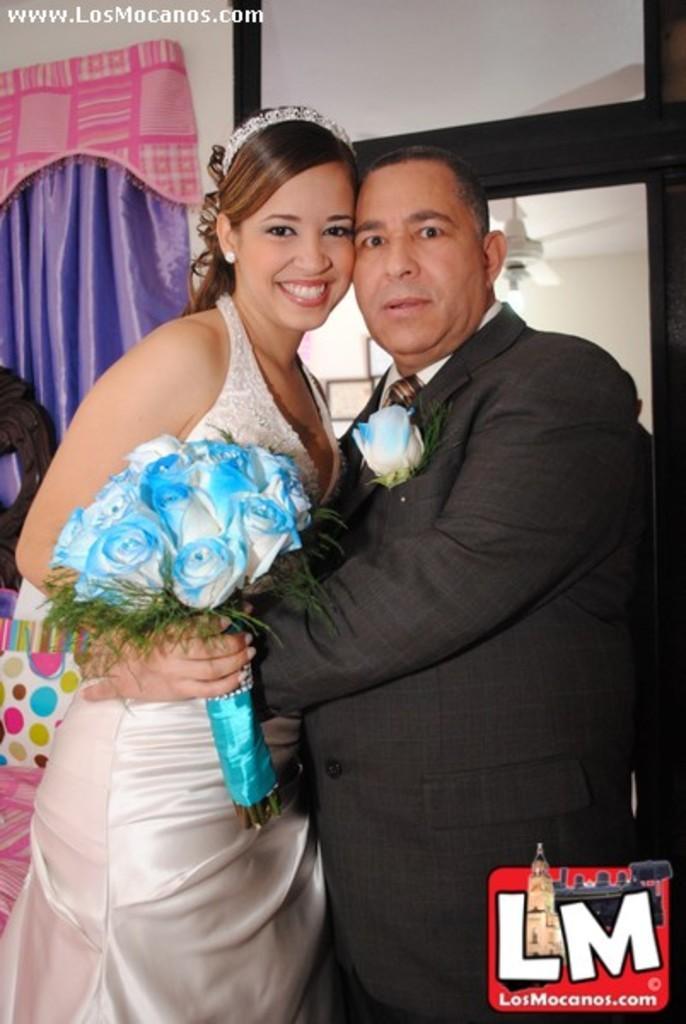How would you summarize this image in a sentence or two? In this image I can see two people are standing and wearing white and black color dresses. They are holding a bouquet. Back I can see the purple curtain and few objects. 